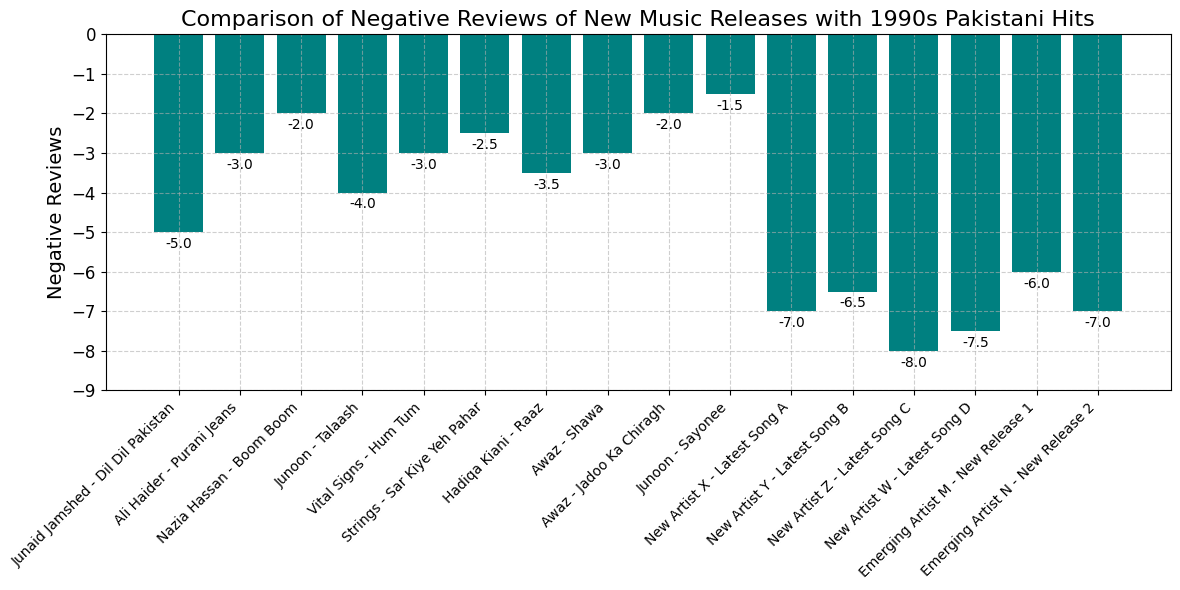What are the two songs from the 1990s with the lowest number of negative reviews? Identify the bars with the least negative reviews within the 1990s period. The bars representing "Junoon - Sayonee" (1999) and "Awaz - Jadoo Ka Chiragh" (1998) are the shortest within this timeframe, indicating they have the least negative reviews.
Answer: "Junoon - Sayonee" and "Awaz - Jadoo Ka Chiragh" Which song received the most negative reviews overall? Look for the tallest bar on the chart as it represents the highest negative reviews. The song "New Artist Z - Latest Song C" in 2022 has the tallest bar, indicating the most negative reviews.
Answer: "New Artist Z - Latest Song C" What is the total number of negative reviews for the music released in 2021? Sum the negative reviews of the songs released in 2021: "New Artist X - Latest Song A" (-7) and "New Artist Y - Latest Song B" (-6.5). The total is -7 + (-6.5) = -13.5.
Answer: -13.5 Which year had the highest combined negative reviews for its songs? Sum the negative reviews of songs for each year and compare. 2022 has two songs: "New Artist Z - Latest Song C" (-8) and "New Artist W - Latest Song D" (-7.5). The total is -8 + (-7.5) = -15.5, which is the highest combined for any year.
Answer: 2022 How much lower are the negative reviews for "Junaid Jamshed - Dil Dil Pakistan" compared to "New Artist X - Latest Song A"? Calculate the difference in negative reviews between both songs. "Junaid Jamshed - Dil Dil Pakistan" has -5 reviews, and "New Artist X - Latest Song A" has -7 reviews. The difference is -5 - (-7) = 2 lower negative reviews.
Answer: 2 negative reviews What is the average negative review score for the 1990s songs? Calculate the average by summing the negative reviews of all the 1990s songs and then dividing by the number of songs. The total is -5 + (-3) + (-2) + (-4) + (-3) + (-2.5) + (-3.5) + (-3) + (-2) + (-1.5) = -30.5 over 10 songs, average = -30.5/10 = -3.05.
Answer: -3.05 Which new release in 2023 has fewer negative reviews? Compare the negative reviews between the two 2023 releases. "Emerging Artist M - New Release 1" has -6, and "Emerging Artist N - New Release 2" has -7. "Emerging Artist M - New Release 1" has fewer negative reviews.
Answer: "Emerging Artist M - New Release 1" What is the difference in negative reviews between the highest and lowest-rated 1990s hits? Identify the highest and lowest negative reviews for 1990s songs. Highest is "Junaid Jamshed - Dil Dil Pakistan" at -5 and lowest is "Junoon - Sayonee" at -1.5. The difference is -5 - (-1.5) = -3.5.
Answer: -3.5 